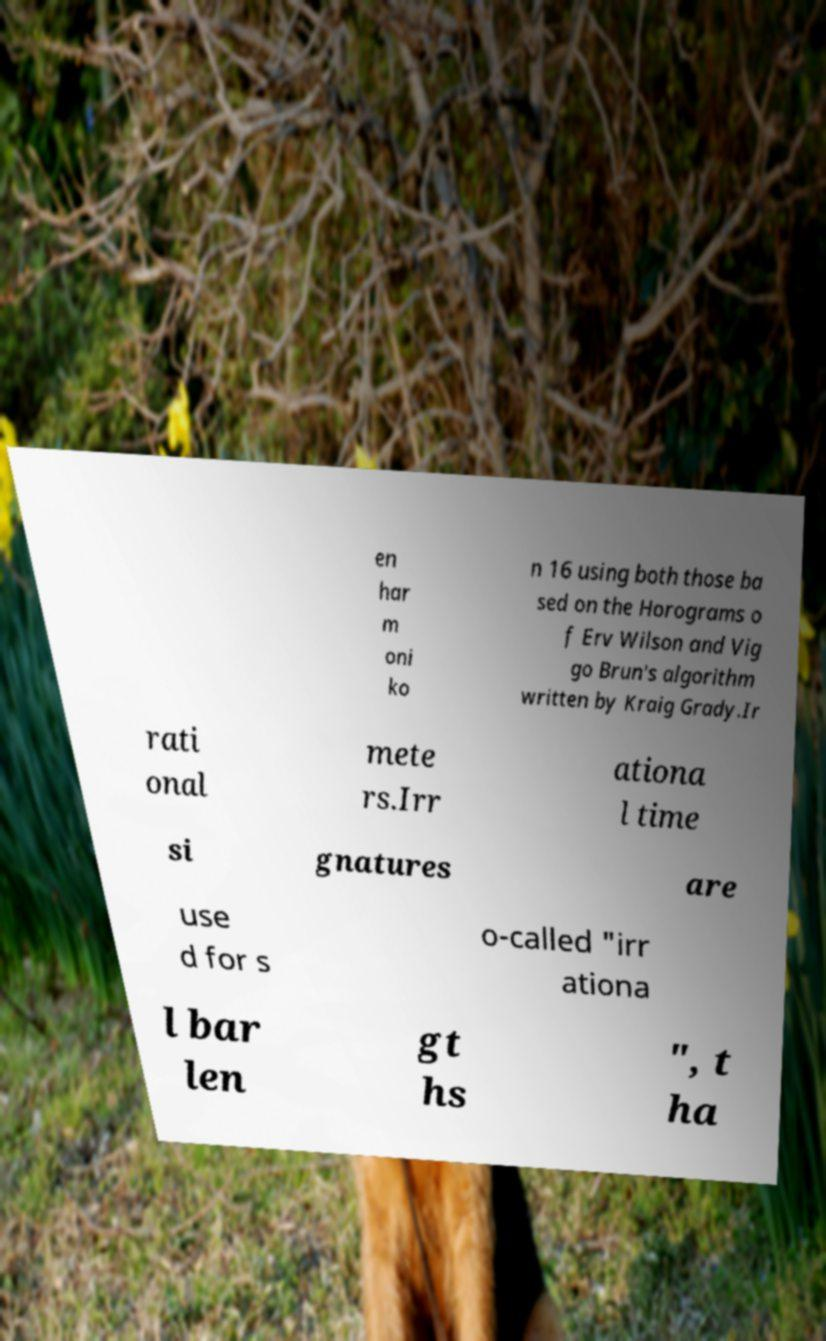Please read and relay the text visible in this image. What does it say? en har m oni ko n 16 using both those ba sed on the Horograms o f Erv Wilson and Vig go Brun's algorithm written by Kraig Grady.Ir rati onal mete rs.Irr ationa l time si gnatures are use d for s o-called "irr ationa l bar len gt hs ", t ha 